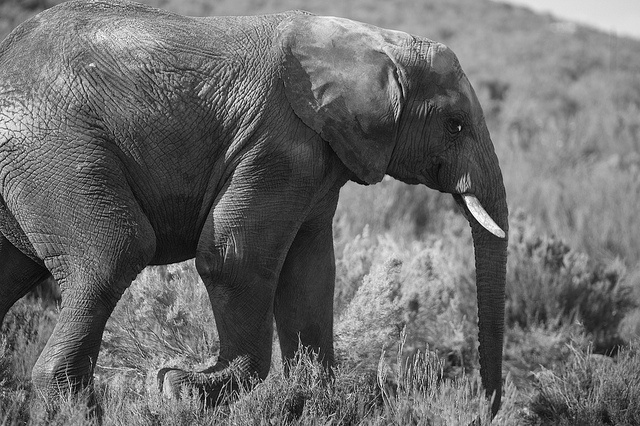Describe the objects in this image and their specific colors. I can see a elephant in black, gray, darkgray, and lightgray tones in this image. 